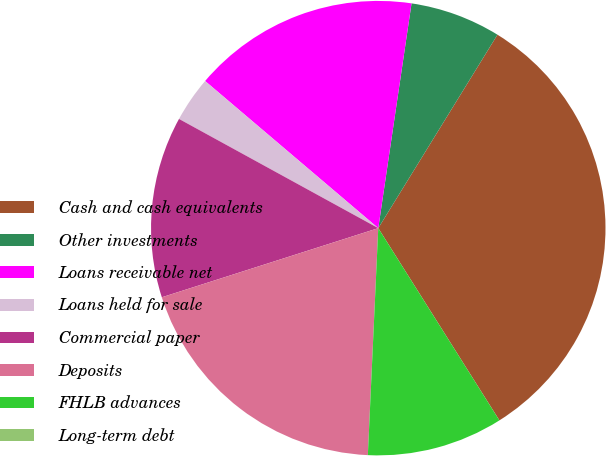Convert chart. <chart><loc_0><loc_0><loc_500><loc_500><pie_chart><fcel>Cash and cash equivalents<fcel>Other investments<fcel>Loans receivable net<fcel>Loans held for sale<fcel>Commercial paper<fcel>Deposits<fcel>FHLB advances<fcel>Long-term debt<nl><fcel>32.26%<fcel>6.45%<fcel>16.13%<fcel>3.23%<fcel>12.9%<fcel>19.35%<fcel>9.68%<fcel>0.0%<nl></chart> 